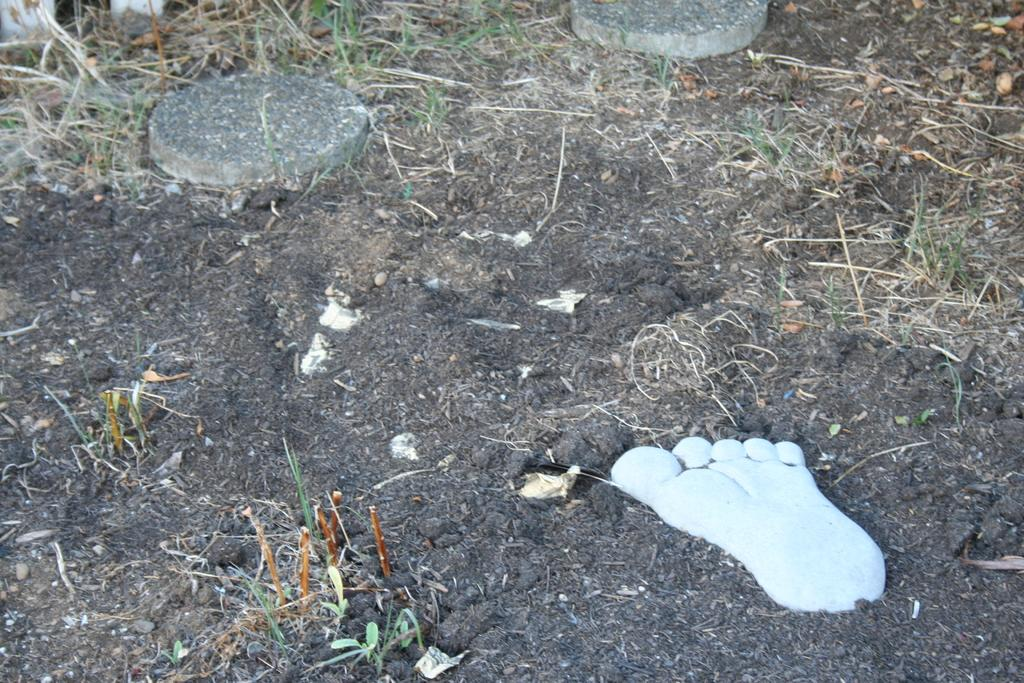What is the color of the object on the ground in the image? The object is white in color. What else can be seen on the ground in the image? There are dry leaves on the ground in the image. What type of vegetation is present in the image? There is grass in the image. Can you see a hen using a spoon to eat the grass in the image? There is no hen or spoon present in the image, and the grass is not being eaten by any animal. 